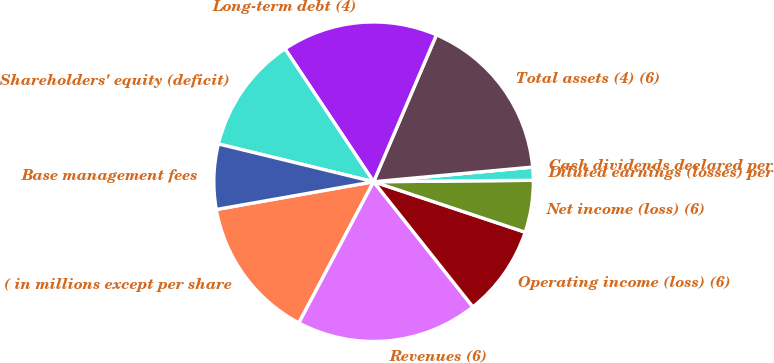Convert chart to OTSL. <chart><loc_0><loc_0><loc_500><loc_500><pie_chart><fcel>( in millions except per share<fcel>Revenues (6)<fcel>Operating income (loss) (6)<fcel>Net income (loss) (6)<fcel>Diluted earnings (losses) per<fcel>Cash dividends declared per<fcel>Total assets (4) (6)<fcel>Long-term debt (4)<fcel>Shareholders' equity (deficit)<fcel>Base management fees<nl><fcel>14.47%<fcel>18.42%<fcel>9.21%<fcel>5.26%<fcel>1.32%<fcel>0.0%<fcel>17.1%<fcel>15.79%<fcel>11.84%<fcel>6.58%<nl></chart> 